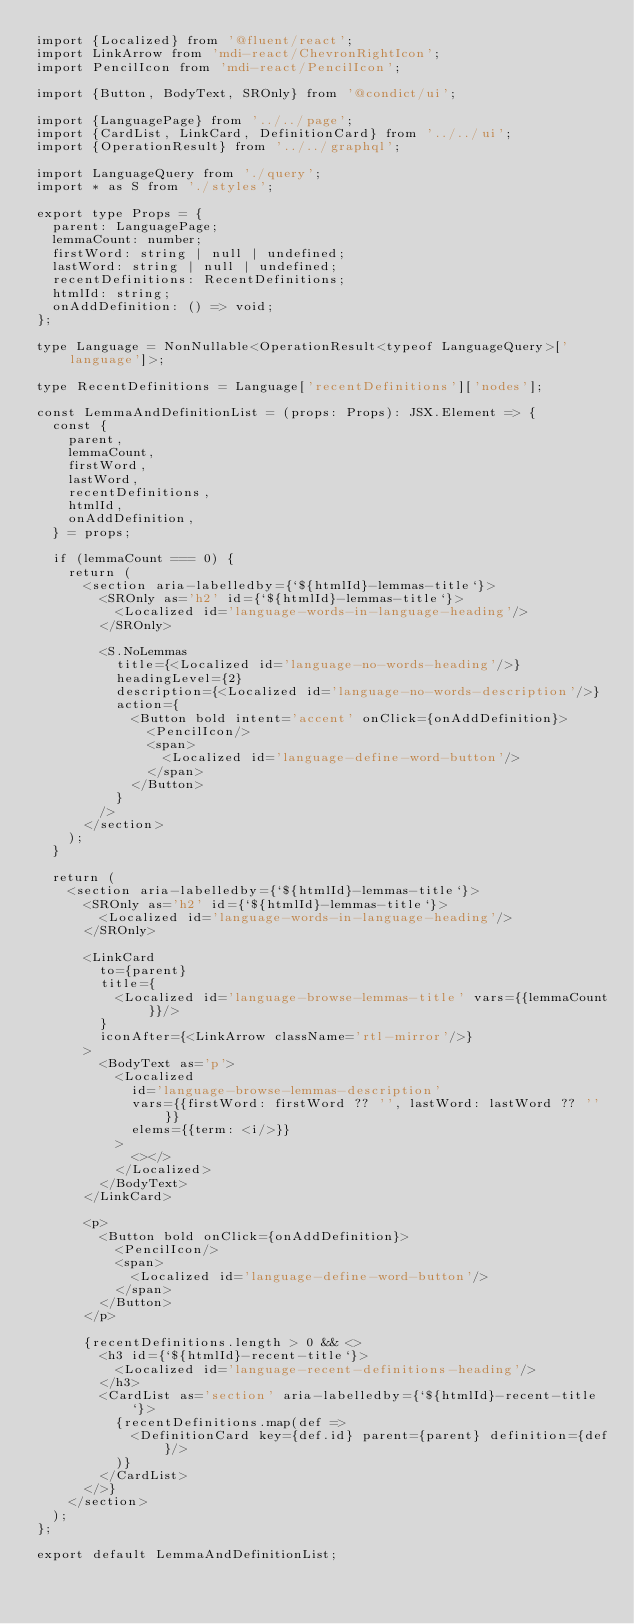Convert code to text. <code><loc_0><loc_0><loc_500><loc_500><_TypeScript_>import {Localized} from '@fluent/react';
import LinkArrow from 'mdi-react/ChevronRightIcon';
import PencilIcon from 'mdi-react/PencilIcon';

import {Button, BodyText, SROnly} from '@condict/ui';

import {LanguagePage} from '../../page';
import {CardList, LinkCard, DefinitionCard} from '../../ui';
import {OperationResult} from '../../graphql';

import LanguageQuery from './query';
import * as S from './styles';

export type Props = {
  parent: LanguagePage;
  lemmaCount: number;
  firstWord: string | null | undefined;
  lastWord: string | null | undefined;
  recentDefinitions: RecentDefinitions;
  htmlId: string;
  onAddDefinition: () => void;
};

type Language = NonNullable<OperationResult<typeof LanguageQuery>['language']>;

type RecentDefinitions = Language['recentDefinitions']['nodes'];

const LemmaAndDefinitionList = (props: Props): JSX.Element => {
  const {
    parent,
    lemmaCount,
    firstWord,
    lastWord,
    recentDefinitions,
    htmlId,
    onAddDefinition,
  } = props;

  if (lemmaCount === 0) {
    return (
      <section aria-labelledby={`${htmlId}-lemmas-title`}>
        <SROnly as='h2' id={`${htmlId}-lemmas-title`}>
          <Localized id='language-words-in-language-heading'/>
        </SROnly>

        <S.NoLemmas
          title={<Localized id='language-no-words-heading'/>}
          headingLevel={2}
          description={<Localized id='language-no-words-description'/>}
          action={
            <Button bold intent='accent' onClick={onAddDefinition}>
              <PencilIcon/>
              <span>
                <Localized id='language-define-word-button'/>
              </span>
            </Button>
          }
        />
      </section>
    );
  }

  return (
    <section aria-labelledby={`${htmlId}-lemmas-title`}>
      <SROnly as='h2' id={`${htmlId}-lemmas-title`}>
        <Localized id='language-words-in-language-heading'/>
      </SROnly>

      <LinkCard
        to={parent}
        title={
          <Localized id='language-browse-lemmas-title' vars={{lemmaCount}}/>
        }
        iconAfter={<LinkArrow className='rtl-mirror'/>}
      >
        <BodyText as='p'>
          <Localized
            id='language-browse-lemmas-description'
            vars={{firstWord: firstWord ?? '', lastWord: lastWord ?? ''}}
            elems={{term: <i/>}}
          >
            <></>
          </Localized>
        </BodyText>
      </LinkCard>

      <p>
        <Button bold onClick={onAddDefinition}>
          <PencilIcon/>
          <span>
            <Localized id='language-define-word-button'/>
          </span>
        </Button>
      </p>

      {recentDefinitions.length > 0 && <>
        <h3 id={`${htmlId}-recent-title`}>
          <Localized id='language-recent-definitions-heading'/>
        </h3>
        <CardList as='section' aria-labelledby={`${htmlId}-recent-title`}>
          {recentDefinitions.map(def =>
            <DefinitionCard key={def.id} parent={parent} definition={def}/>
          )}
        </CardList>
      </>}
    </section>
  );
};

export default LemmaAndDefinitionList;
</code> 